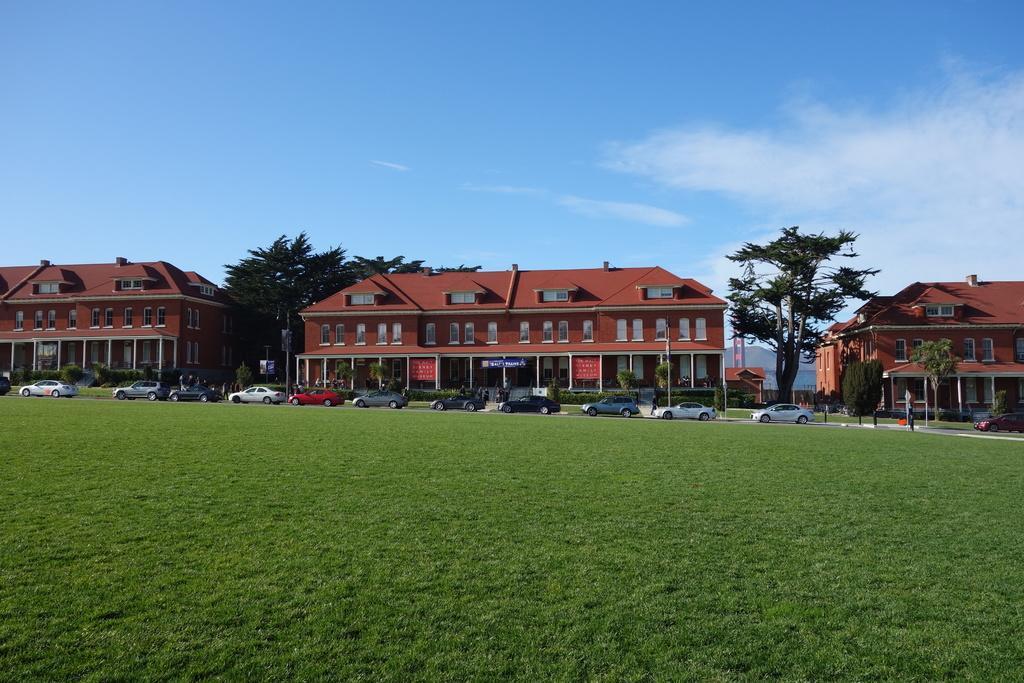How would you summarize this image in a sentence or two? At the bottom we can see grass on the ground. In the background there are vehicles on the road,buildings,mountains,windows,poles,banners,hoardings,plants and clouds in the sky. 